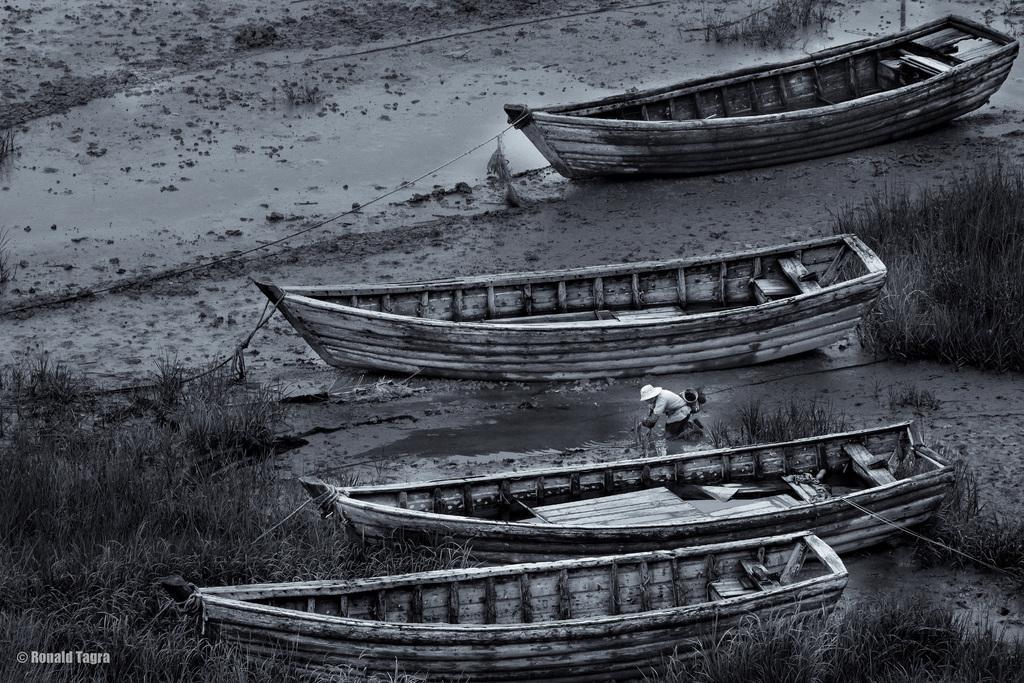Please provide a concise description of this image. Here we can see boats and grass. There is a person standing on mud. 